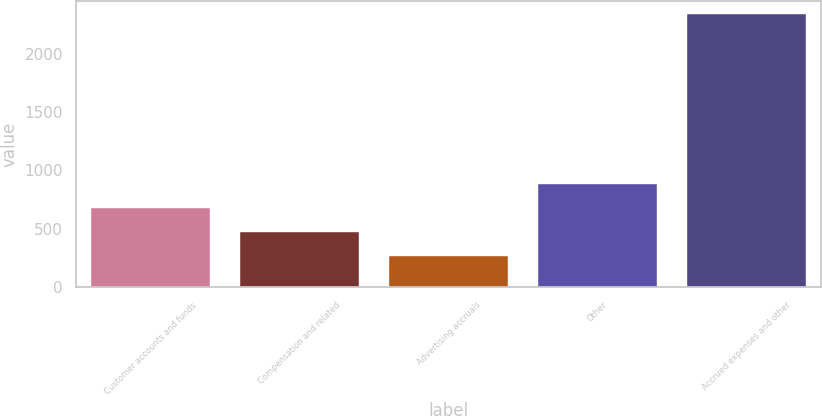Convert chart. <chart><loc_0><loc_0><loc_500><loc_500><bar_chart><fcel>Customer accounts and funds<fcel>Compensation and related<fcel>Advertising accruals<fcel>Other<fcel>Accrued expenses and other<nl><fcel>681<fcel>471.1<fcel>264<fcel>888.1<fcel>2335<nl></chart> 